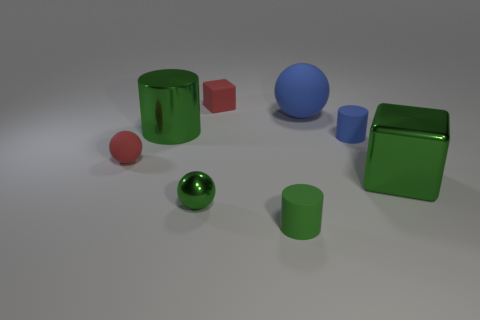Is the number of small green shiny things that are behind the big blue rubber sphere less than the number of red matte things that are behind the tiny red matte ball?
Your answer should be very brief. Yes. There is a metal object that is the same shape as the green rubber object; what color is it?
Ensure brevity in your answer.  Green. Does the tiny blue object have the same shape as the green shiny object that is behind the small blue thing?
Your response must be concise. Yes. What number of things are either matte cylinders behind the large metallic block or matte things that are right of the shiny cylinder?
Make the answer very short. 4. What is the material of the green sphere?
Your answer should be very brief. Metal. How many other objects are the same size as the green shiny block?
Your response must be concise. 2. What is the size of the rubber cylinder in front of the tiny red ball?
Your response must be concise. Small. There is a red object on the right side of the green cylinder behind the red thing that is to the left of the tiny green metallic thing; what is its material?
Keep it short and to the point. Rubber. Does the small green shiny object have the same shape as the big blue object?
Offer a terse response. Yes. How many metal objects are tiny blue cylinders or red objects?
Your response must be concise. 0. 